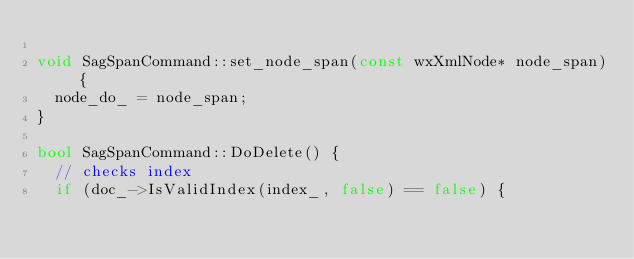Convert code to text. <code><loc_0><loc_0><loc_500><loc_500><_C++_>
void SagSpanCommand::set_node_span(const wxXmlNode* node_span) {
  node_do_ = node_span;
}

bool SagSpanCommand::DoDelete() {
  // checks index
  if (doc_->IsValidIndex(index_, false) == false) {</code> 